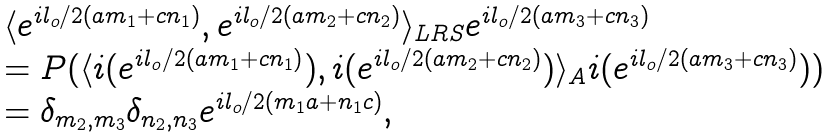<formula> <loc_0><loc_0><loc_500><loc_500>\begin{array} { l } \langle e ^ { i l _ { o } / 2 ( a m _ { 1 } + c n _ { 1 } ) } , e ^ { i l _ { o } / 2 ( a m _ { 2 } + c n _ { 2 } ) } \rangle _ { L R S } e ^ { i l _ { o } / 2 ( a m _ { 3 } + c n _ { 3 } ) } \\ = P ( \langle i ( e ^ { i l _ { o } / 2 ( a m _ { 1 } + c n _ { 1 } ) } ) , i ( e ^ { i l _ { o } / 2 ( a m _ { 2 } + c n _ { 2 } ) } ) \rangle _ { A } i ( e ^ { i l _ { o } / 2 ( a m _ { 3 } + c n _ { 3 } ) } ) ) \\ = \delta _ { m _ { 2 } , m _ { 3 } } \delta _ { n _ { 2 } , n _ { 3 } } e ^ { i l _ { o } / 2 ( m _ { 1 } a + n _ { 1 } c ) } , \end{array}</formula> 